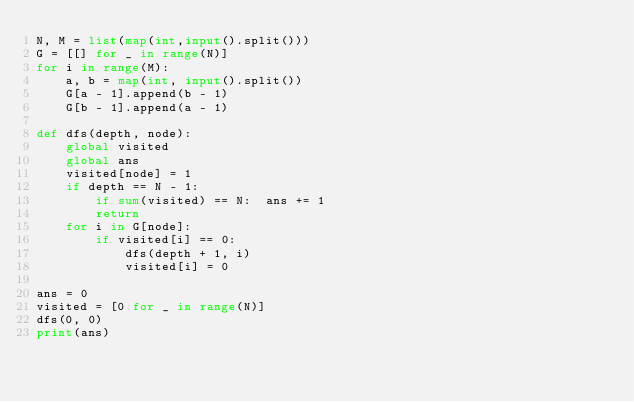Convert code to text. <code><loc_0><loc_0><loc_500><loc_500><_Python_>N, M = list(map(int,input().split()))
G = [[] for _ in range(N)]
for i in range(M):
    a, b = map(int, input().split())
    G[a - 1].append(b - 1)
    G[b - 1].append(a - 1)

def dfs(depth, node):
    global visited
    global ans
    visited[node] = 1
    if depth == N - 1:
        if sum(visited) == N:  ans += 1
        return
    for i in G[node]:
        if visited[i] == 0:
            dfs(depth + 1, i)
            visited[i] = 0
            
ans = 0
visited = [0 for _ in range(N)]
dfs(0, 0)
print(ans)</code> 